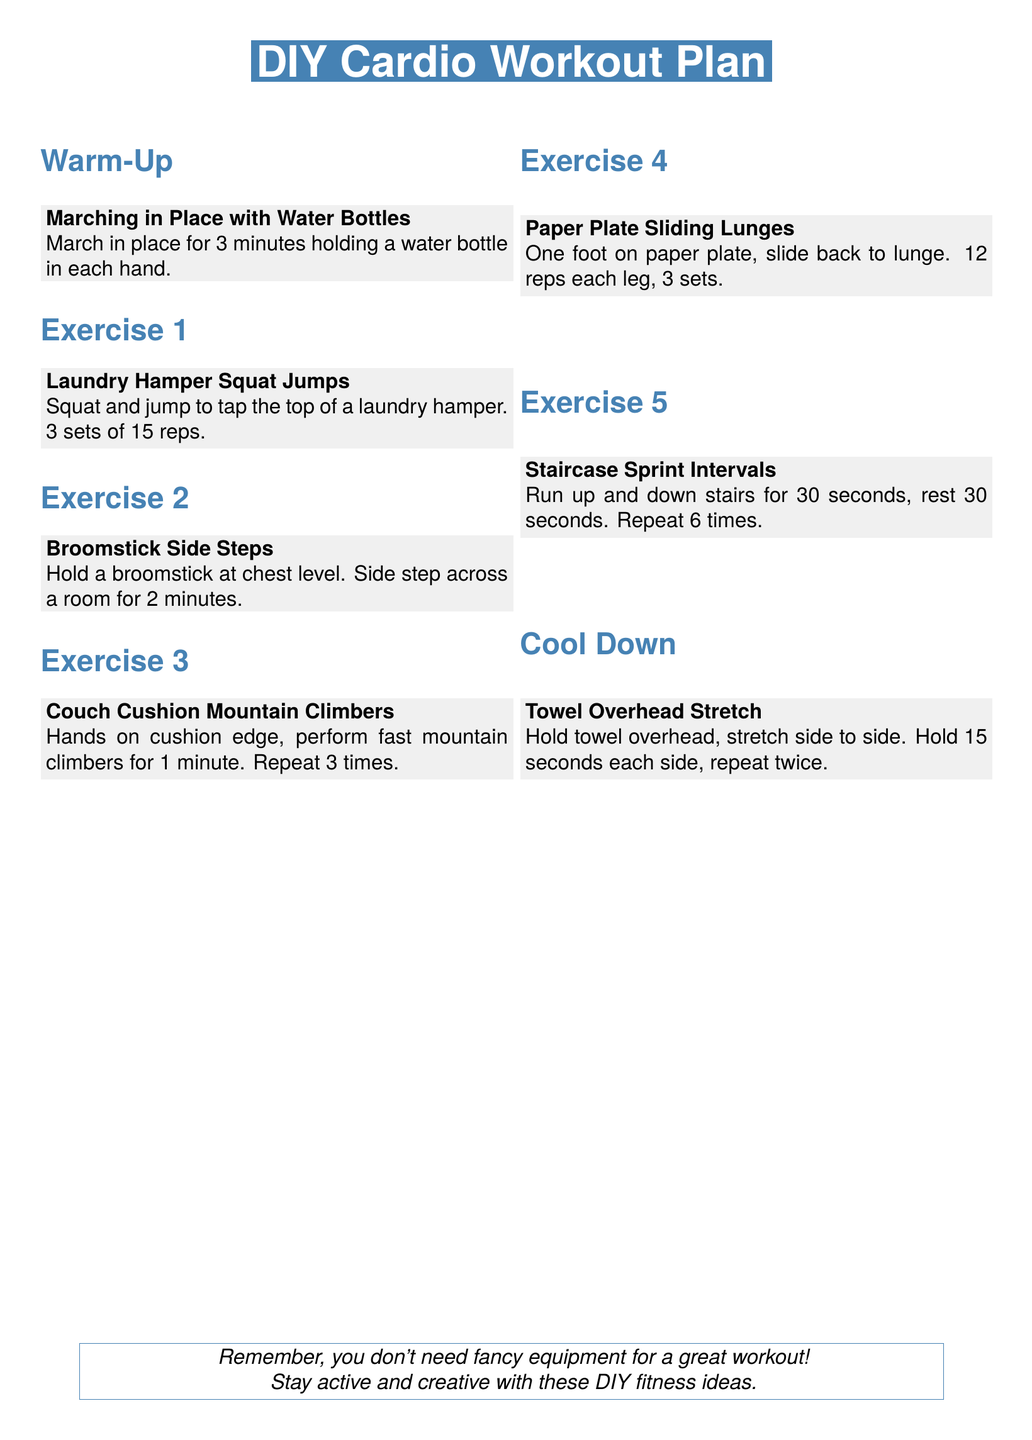what is the title of the workout plan? The title is prominently displayed at the top of the document.
Answer: DIY Cardio Workout Plan how long should you march in place with water bottles? The warm-up section specifies the duration for this exercise.
Answer: 3 minutes how many sets of laundry hamper squat jumps should be performed? The exercise details include the number of sets for this activity.
Answer: 3 sets what is the duration for broomstick side steps? The exercise description specifies how long to perform this activity.
Answer: 2 minutes how many times should you repeat the couch cushion mountain climbers? The exercise instructions indicate the number of repetitions for this exercise.
Answer: 3 times what is the total duration of staircase sprint intervals including rest? The document specifies the work and rest periods for these intervals.
Answer: 6 times (30 seconds each) how do you cool down after the workout? This section describes the cool-down activity post-exercise.
Answer: Towel Overhead Stretch how many repetitions of lunges are recommended for each leg? The exercise details specify the number of reps for this activity.
Answer: 12 reps each leg 